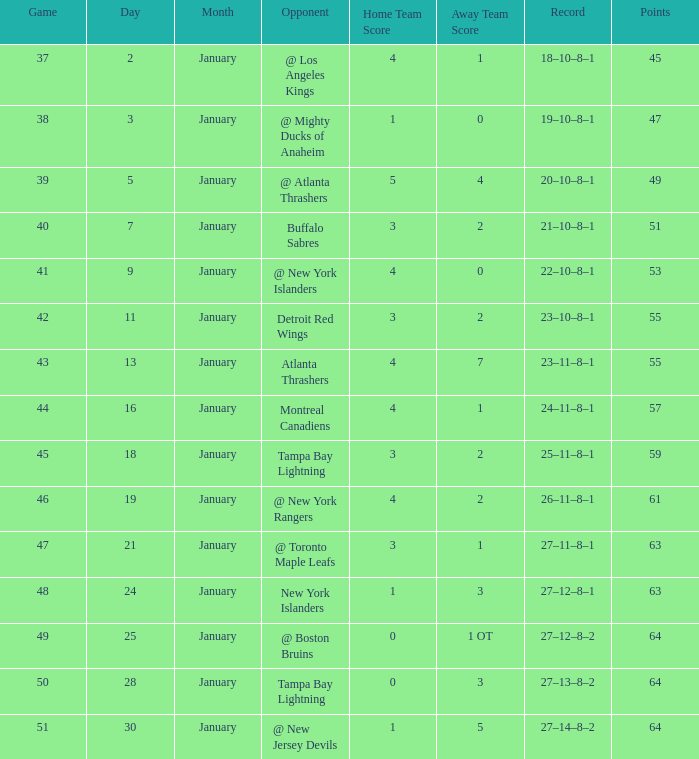How many Games have a Score of 5–4, and Points smaller than 49? 0.0. 